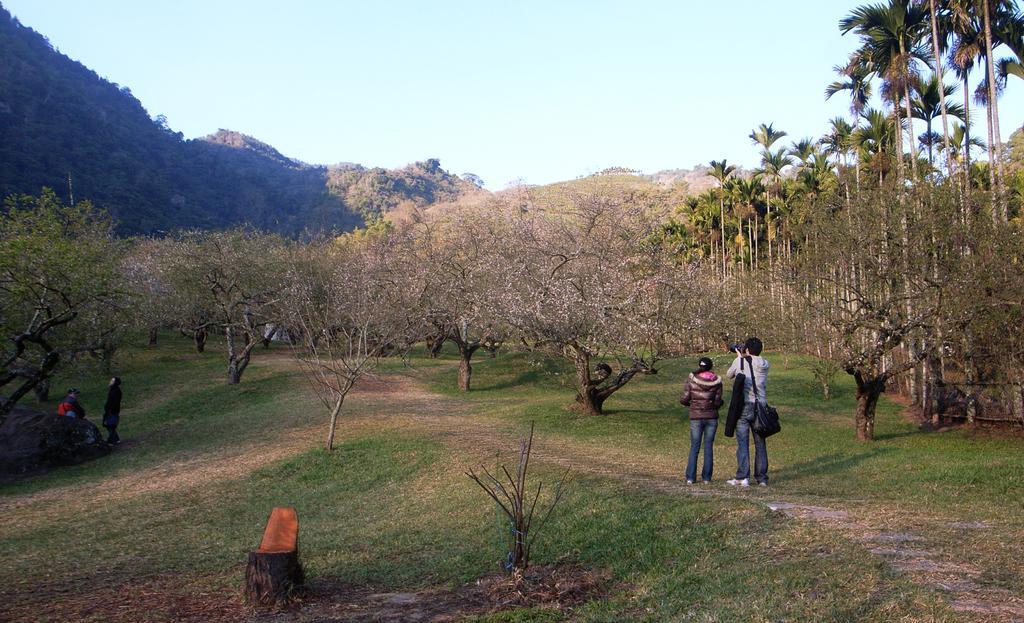Describe this image in one or two sentences. In this picture there are two person standing on the land. There is a man who is wearing black guitar bag, shirt, jeans and shoe. He is also holding camera. Besides him we can see a woman who is wearing jacket, jeans and shoe. On the bottom we can see grass. On the left we can see group of persons standing near to the tree. On the background we can see mountains and many trees. On the top there is a sky. 